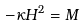Convert formula to latex. <formula><loc_0><loc_0><loc_500><loc_500>- \kappa H ^ { 2 } = M</formula> 